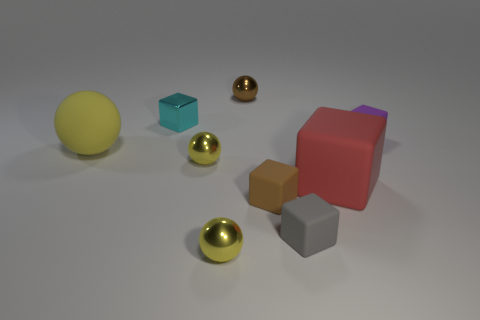Subtract all yellow spheres. How many were subtracted if there are1yellow spheres left? 2 Subtract all purple cubes. How many yellow spheres are left? 3 Subtract all purple cubes. How many cubes are left? 4 Subtract all small gray rubber cubes. How many cubes are left? 4 Subtract all blue blocks. Subtract all yellow cylinders. How many blocks are left? 5 Add 1 large yellow rubber objects. How many objects exist? 10 Subtract all spheres. How many objects are left? 5 Add 6 purple things. How many purple things are left? 7 Add 3 large red metal objects. How many large red metal objects exist? 3 Subtract 0 cyan cylinders. How many objects are left? 9 